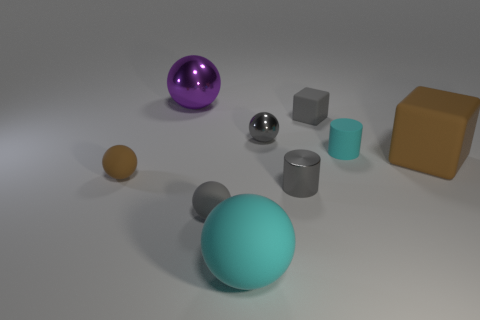What material is the large object that is both behind the small brown ball and right of the large purple thing?
Provide a short and direct response. Rubber. How many brown matte balls are the same size as the gray matte sphere?
Provide a short and direct response. 1. What number of rubber things are either purple objects or yellow things?
Ensure brevity in your answer.  0. What is the material of the brown ball?
Offer a terse response. Rubber. How many tiny gray shiny things are on the left side of the large cube?
Provide a short and direct response. 2. Does the gray ball that is in front of the tiny brown matte ball have the same material as the big purple thing?
Your answer should be very brief. No. What number of small brown matte objects are the same shape as the large purple metal object?
Your answer should be compact. 1. What number of big objects are cyan matte balls or rubber cubes?
Make the answer very short. 2. Does the big rubber thing that is to the right of the small metal cylinder have the same color as the tiny shiny cylinder?
Offer a very short reply. No. Do the big matte thing that is behind the large cyan ball and the rubber ball on the left side of the purple object have the same color?
Offer a terse response. Yes. 